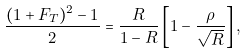<formula> <loc_0><loc_0><loc_500><loc_500>\frac { ( 1 + F _ { T } ) ^ { 2 } - 1 } { 2 } = \frac { R } { 1 - R } \left [ 1 - \frac { \rho } { \sqrt { R } } \right ] ,</formula> 